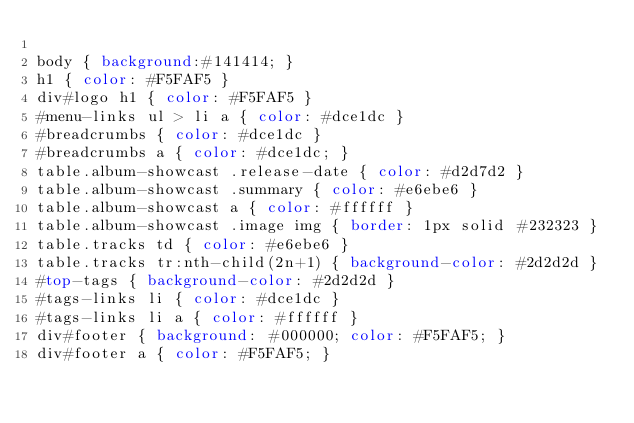<code> <loc_0><loc_0><loc_500><loc_500><_CSS_>
body { background:#141414; }
h1 { color: #F5FAF5 }
div#logo h1 { color: #F5FAF5 }
#menu-links ul > li a { color: #dce1dc }
#breadcrumbs { color: #dce1dc }
#breadcrumbs a { color: #dce1dc; }
table.album-showcast .release-date { color: #d2d7d2 }
table.album-showcast .summary { color: #e6ebe6 }
table.album-showcast a { color: #ffffff }
table.album-showcast .image img { border: 1px solid #232323 }
table.tracks td { color: #e6ebe6 }
table.tracks tr:nth-child(2n+1) { background-color: #2d2d2d }
#top-tags { background-color: #2d2d2d }
#tags-links li { color: #dce1dc }
#tags-links li a { color: #ffffff }
div#footer { background: #000000; color: #F5FAF5; }
div#footer a { color: #F5FAF5; }
</code> 